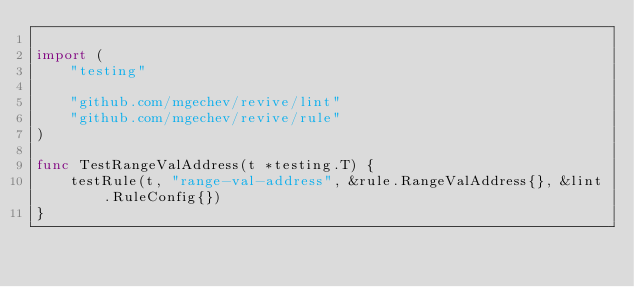Convert code to text. <code><loc_0><loc_0><loc_500><loc_500><_Go_>
import (
	"testing"

	"github.com/mgechev/revive/lint"
	"github.com/mgechev/revive/rule"
)

func TestRangeValAddress(t *testing.T) {
	testRule(t, "range-val-address", &rule.RangeValAddress{}, &lint.RuleConfig{})
}
</code> 